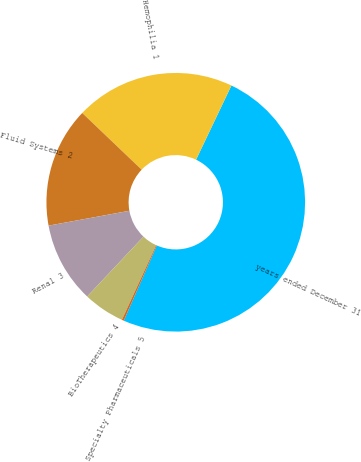<chart> <loc_0><loc_0><loc_500><loc_500><pie_chart><fcel>years ended December 31<fcel>Hemophilia 1<fcel>Fluid Systems 2<fcel>Renal 3<fcel>BioTherapeutics 4<fcel>Specialty Pharmaceuticals 5<nl><fcel>49.51%<fcel>19.95%<fcel>15.02%<fcel>10.1%<fcel>5.17%<fcel>0.25%<nl></chart> 